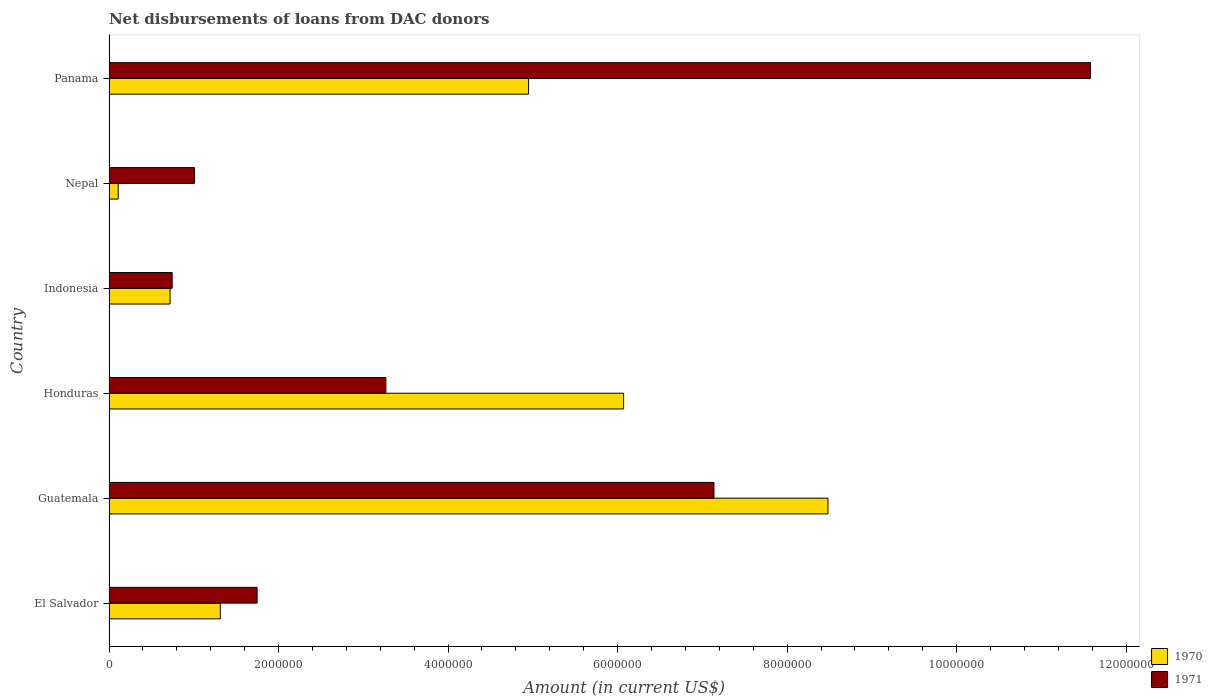Are the number of bars on each tick of the Y-axis equal?
Give a very brief answer. Yes. How many bars are there on the 4th tick from the top?
Make the answer very short. 2. How many bars are there on the 6th tick from the bottom?
Your answer should be very brief. 2. What is the label of the 4th group of bars from the top?
Ensure brevity in your answer.  Honduras. In how many cases, is the number of bars for a given country not equal to the number of legend labels?
Provide a succinct answer. 0. What is the amount of loans disbursed in 1971 in Guatemala?
Your response must be concise. 7.14e+06. Across all countries, what is the maximum amount of loans disbursed in 1970?
Your answer should be very brief. 8.48e+06. Across all countries, what is the minimum amount of loans disbursed in 1970?
Provide a short and direct response. 1.09e+05. In which country was the amount of loans disbursed in 1971 maximum?
Provide a short and direct response. Panama. In which country was the amount of loans disbursed in 1970 minimum?
Offer a very short reply. Nepal. What is the total amount of loans disbursed in 1970 in the graph?
Provide a short and direct response. 2.16e+07. What is the difference between the amount of loans disbursed in 1971 in Guatemala and that in Nepal?
Give a very brief answer. 6.13e+06. What is the difference between the amount of loans disbursed in 1970 in Nepal and the amount of loans disbursed in 1971 in Guatemala?
Make the answer very short. -7.03e+06. What is the average amount of loans disbursed in 1970 per country?
Your answer should be very brief. 3.61e+06. What is the difference between the amount of loans disbursed in 1970 and amount of loans disbursed in 1971 in Indonesia?
Provide a succinct answer. -2.50e+04. In how many countries, is the amount of loans disbursed in 1971 greater than 8000000 US$?
Your answer should be very brief. 1. What is the ratio of the amount of loans disbursed in 1971 in Guatemala to that in Panama?
Make the answer very short. 0.62. Is the amount of loans disbursed in 1971 in Guatemala less than that in Panama?
Give a very brief answer. Yes. What is the difference between the highest and the second highest amount of loans disbursed in 1970?
Give a very brief answer. 2.41e+06. What is the difference between the highest and the lowest amount of loans disbursed in 1971?
Your response must be concise. 1.08e+07. What does the 1st bar from the bottom in Guatemala represents?
Your answer should be compact. 1970. Are all the bars in the graph horizontal?
Provide a short and direct response. Yes. Does the graph contain any zero values?
Your answer should be compact. No. Does the graph contain grids?
Give a very brief answer. No. How many legend labels are there?
Your response must be concise. 2. How are the legend labels stacked?
Ensure brevity in your answer.  Vertical. What is the title of the graph?
Your response must be concise. Net disbursements of loans from DAC donors. Does "1969" appear as one of the legend labels in the graph?
Offer a terse response. No. What is the label or title of the X-axis?
Your answer should be compact. Amount (in current US$). What is the label or title of the Y-axis?
Keep it short and to the point. Country. What is the Amount (in current US$) in 1970 in El Salvador?
Provide a short and direct response. 1.31e+06. What is the Amount (in current US$) in 1971 in El Salvador?
Offer a very short reply. 1.75e+06. What is the Amount (in current US$) in 1970 in Guatemala?
Your answer should be very brief. 8.48e+06. What is the Amount (in current US$) in 1971 in Guatemala?
Offer a terse response. 7.14e+06. What is the Amount (in current US$) of 1970 in Honduras?
Provide a succinct answer. 6.07e+06. What is the Amount (in current US$) of 1971 in Honduras?
Give a very brief answer. 3.27e+06. What is the Amount (in current US$) in 1970 in Indonesia?
Your answer should be very brief. 7.20e+05. What is the Amount (in current US$) of 1971 in Indonesia?
Offer a terse response. 7.45e+05. What is the Amount (in current US$) of 1970 in Nepal?
Your answer should be compact. 1.09e+05. What is the Amount (in current US$) of 1971 in Nepal?
Your answer should be very brief. 1.01e+06. What is the Amount (in current US$) in 1970 in Panama?
Your answer should be compact. 4.95e+06. What is the Amount (in current US$) of 1971 in Panama?
Give a very brief answer. 1.16e+07. Across all countries, what is the maximum Amount (in current US$) of 1970?
Offer a terse response. 8.48e+06. Across all countries, what is the maximum Amount (in current US$) of 1971?
Your response must be concise. 1.16e+07. Across all countries, what is the minimum Amount (in current US$) of 1970?
Your response must be concise. 1.09e+05. Across all countries, what is the minimum Amount (in current US$) of 1971?
Keep it short and to the point. 7.45e+05. What is the total Amount (in current US$) in 1970 in the graph?
Offer a terse response. 2.16e+07. What is the total Amount (in current US$) in 1971 in the graph?
Your answer should be very brief. 2.55e+07. What is the difference between the Amount (in current US$) of 1970 in El Salvador and that in Guatemala?
Ensure brevity in your answer.  -7.17e+06. What is the difference between the Amount (in current US$) in 1971 in El Salvador and that in Guatemala?
Keep it short and to the point. -5.39e+06. What is the difference between the Amount (in current US$) of 1970 in El Salvador and that in Honduras?
Offer a very short reply. -4.76e+06. What is the difference between the Amount (in current US$) of 1971 in El Salvador and that in Honduras?
Provide a succinct answer. -1.52e+06. What is the difference between the Amount (in current US$) of 1970 in El Salvador and that in Indonesia?
Keep it short and to the point. 5.93e+05. What is the difference between the Amount (in current US$) of 1971 in El Salvador and that in Indonesia?
Your answer should be compact. 1.00e+06. What is the difference between the Amount (in current US$) of 1970 in El Salvador and that in Nepal?
Offer a very short reply. 1.20e+06. What is the difference between the Amount (in current US$) of 1971 in El Salvador and that in Nepal?
Provide a short and direct response. 7.39e+05. What is the difference between the Amount (in current US$) in 1970 in El Salvador and that in Panama?
Ensure brevity in your answer.  -3.64e+06. What is the difference between the Amount (in current US$) of 1971 in El Salvador and that in Panama?
Your answer should be compact. -9.83e+06. What is the difference between the Amount (in current US$) of 1970 in Guatemala and that in Honduras?
Offer a very short reply. 2.41e+06. What is the difference between the Amount (in current US$) of 1971 in Guatemala and that in Honduras?
Ensure brevity in your answer.  3.87e+06. What is the difference between the Amount (in current US$) in 1970 in Guatemala and that in Indonesia?
Offer a terse response. 7.76e+06. What is the difference between the Amount (in current US$) in 1971 in Guatemala and that in Indonesia?
Your response must be concise. 6.39e+06. What is the difference between the Amount (in current US$) in 1970 in Guatemala and that in Nepal?
Give a very brief answer. 8.37e+06. What is the difference between the Amount (in current US$) in 1971 in Guatemala and that in Nepal?
Offer a very short reply. 6.13e+06. What is the difference between the Amount (in current US$) of 1970 in Guatemala and that in Panama?
Offer a terse response. 3.53e+06. What is the difference between the Amount (in current US$) of 1971 in Guatemala and that in Panama?
Provide a succinct answer. -4.44e+06. What is the difference between the Amount (in current US$) of 1970 in Honduras and that in Indonesia?
Your answer should be compact. 5.35e+06. What is the difference between the Amount (in current US$) in 1971 in Honduras and that in Indonesia?
Your answer should be very brief. 2.52e+06. What is the difference between the Amount (in current US$) of 1970 in Honduras and that in Nepal?
Your answer should be compact. 5.96e+06. What is the difference between the Amount (in current US$) of 1971 in Honduras and that in Nepal?
Provide a succinct answer. 2.26e+06. What is the difference between the Amount (in current US$) of 1970 in Honduras and that in Panama?
Your answer should be compact. 1.12e+06. What is the difference between the Amount (in current US$) in 1971 in Honduras and that in Panama?
Provide a short and direct response. -8.31e+06. What is the difference between the Amount (in current US$) of 1970 in Indonesia and that in Nepal?
Offer a terse response. 6.11e+05. What is the difference between the Amount (in current US$) of 1971 in Indonesia and that in Nepal?
Make the answer very short. -2.63e+05. What is the difference between the Amount (in current US$) of 1970 in Indonesia and that in Panama?
Your response must be concise. -4.23e+06. What is the difference between the Amount (in current US$) in 1971 in Indonesia and that in Panama?
Give a very brief answer. -1.08e+07. What is the difference between the Amount (in current US$) of 1970 in Nepal and that in Panama?
Make the answer very short. -4.84e+06. What is the difference between the Amount (in current US$) in 1971 in Nepal and that in Panama?
Provide a short and direct response. -1.06e+07. What is the difference between the Amount (in current US$) in 1970 in El Salvador and the Amount (in current US$) in 1971 in Guatemala?
Your response must be concise. -5.82e+06. What is the difference between the Amount (in current US$) in 1970 in El Salvador and the Amount (in current US$) in 1971 in Honduras?
Your response must be concise. -1.95e+06. What is the difference between the Amount (in current US$) of 1970 in El Salvador and the Amount (in current US$) of 1971 in Indonesia?
Provide a succinct answer. 5.68e+05. What is the difference between the Amount (in current US$) of 1970 in El Salvador and the Amount (in current US$) of 1971 in Nepal?
Give a very brief answer. 3.05e+05. What is the difference between the Amount (in current US$) in 1970 in El Salvador and the Amount (in current US$) in 1971 in Panama?
Provide a short and direct response. -1.03e+07. What is the difference between the Amount (in current US$) in 1970 in Guatemala and the Amount (in current US$) in 1971 in Honduras?
Offer a terse response. 5.22e+06. What is the difference between the Amount (in current US$) in 1970 in Guatemala and the Amount (in current US$) in 1971 in Indonesia?
Provide a succinct answer. 7.74e+06. What is the difference between the Amount (in current US$) in 1970 in Guatemala and the Amount (in current US$) in 1971 in Nepal?
Your answer should be very brief. 7.47e+06. What is the difference between the Amount (in current US$) of 1970 in Guatemala and the Amount (in current US$) of 1971 in Panama?
Your answer should be very brief. -3.10e+06. What is the difference between the Amount (in current US$) of 1970 in Honduras and the Amount (in current US$) of 1971 in Indonesia?
Make the answer very short. 5.33e+06. What is the difference between the Amount (in current US$) in 1970 in Honduras and the Amount (in current US$) in 1971 in Nepal?
Offer a terse response. 5.06e+06. What is the difference between the Amount (in current US$) of 1970 in Honduras and the Amount (in current US$) of 1971 in Panama?
Offer a terse response. -5.51e+06. What is the difference between the Amount (in current US$) in 1970 in Indonesia and the Amount (in current US$) in 1971 in Nepal?
Provide a short and direct response. -2.88e+05. What is the difference between the Amount (in current US$) of 1970 in Indonesia and the Amount (in current US$) of 1971 in Panama?
Offer a terse response. -1.09e+07. What is the difference between the Amount (in current US$) of 1970 in Nepal and the Amount (in current US$) of 1971 in Panama?
Ensure brevity in your answer.  -1.15e+07. What is the average Amount (in current US$) of 1970 per country?
Give a very brief answer. 3.61e+06. What is the average Amount (in current US$) in 1971 per country?
Provide a succinct answer. 4.25e+06. What is the difference between the Amount (in current US$) of 1970 and Amount (in current US$) of 1971 in El Salvador?
Give a very brief answer. -4.34e+05. What is the difference between the Amount (in current US$) in 1970 and Amount (in current US$) in 1971 in Guatemala?
Your response must be concise. 1.34e+06. What is the difference between the Amount (in current US$) of 1970 and Amount (in current US$) of 1971 in Honduras?
Offer a very short reply. 2.80e+06. What is the difference between the Amount (in current US$) of 1970 and Amount (in current US$) of 1971 in Indonesia?
Your answer should be very brief. -2.50e+04. What is the difference between the Amount (in current US$) of 1970 and Amount (in current US$) of 1971 in Nepal?
Your answer should be compact. -8.99e+05. What is the difference between the Amount (in current US$) of 1970 and Amount (in current US$) of 1971 in Panama?
Your answer should be very brief. -6.63e+06. What is the ratio of the Amount (in current US$) of 1970 in El Salvador to that in Guatemala?
Your answer should be compact. 0.15. What is the ratio of the Amount (in current US$) of 1971 in El Salvador to that in Guatemala?
Ensure brevity in your answer.  0.24. What is the ratio of the Amount (in current US$) in 1970 in El Salvador to that in Honduras?
Provide a succinct answer. 0.22. What is the ratio of the Amount (in current US$) in 1971 in El Salvador to that in Honduras?
Ensure brevity in your answer.  0.53. What is the ratio of the Amount (in current US$) in 1970 in El Salvador to that in Indonesia?
Keep it short and to the point. 1.82. What is the ratio of the Amount (in current US$) in 1971 in El Salvador to that in Indonesia?
Give a very brief answer. 2.35. What is the ratio of the Amount (in current US$) in 1970 in El Salvador to that in Nepal?
Provide a short and direct response. 12.05. What is the ratio of the Amount (in current US$) of 1971 in El Salvador to that in Nepal?
Provide a succinct answer. 1.73. What is the ratio of the Amount (in current US$) in 1970 in El Salvador to that in Panama?
Offer a very short reply. 0.27. What is the ratio of the Amount (in current US$) of 1971 in El Salvador to that in Panama?
Make the answer very short. 0.15. What is the ratio of the Amount (in current US$) in 1970 in Guatemala to that in Honduras?
Give a very brief answer. 1.4. What is the ratio of the Amount (in current US$) of 1971 in Guatemala to that in Honduras?
Provide a succinct answer. 2.19. What is the ratio of the Amount (in current US$) in 1970 in Guatemala to that in Indonesia?
Provide a short and direct response. 11.78. What is the ratio of the Amount (in current US$) of 1971 in Guatemala to that in Indonesia?
Your response must be concise. 9.58. What is the ratio of the Amount (in current US$) of 1970 in Guatemala to that in Nepal?
Provide a short and direct response. 77.82. What is the ratio of the Amount (in current US$) in 1971 in Guatemala to that in Nepal?
Your answer should be very brief. 7.08. What is the ratio of the Amount (in current US$) in 1970 in Guatemala to that in Panama?
Your answer should be compact. 1.71. What is the ratio of the Amount (in current US$) of 1971 in Guatemala to that in Panama?
Make the answer very short. 0.62. What is the ratio of the Amount (in current US$) in 1970 in Honduras to that in Indonesia?
Your answer should be compact. 8.43. What is the ratio of the Amount (in current US$) in 1971 in Honduras to that in Indonesia?
Make the answer very short. 4.38. What is the ratio of the Amount (in current US$) in 1970 in Honduras to that in Nepal?
Your answer should be compact. 55.7. What is the ratio of the Amount (in current US$) in 1971 in Honduras to that in Nepal?
Offer a terse response. 3.24. What is the ratio of the Amount (in current US$) of 1970 in Honduras to that in Panama?
Your answer should be very brief. 1.23. What is the ratio of the Amount (in current US$) in 1971 in Honduras to that in Panama?
Provide a short and direct response. 0.28. What is the ratio of the Amount (in current US$) of 1970 in Indonesia to that in Nepal?
Provide a succinct answer. 6.61. What is the ratio of the Amount (in current US$) of 1971 in Indonesia to that in Nepal?
Offer a very short reply. 0.74. What is the ratio of the Amount (in current US$) in 1970 in Indonesia to that in Panama?
Ensure brevity in your answer.  0.15. What is the ratio of the Amount (in current US$) in 1971 in Indonesia to that in Panama?
Provide a succinct answer. 0.06. What is the ratio of the Amount (in current US$) in 1970 in Nepal to that in Panama?
Give a very brief answer. 0.02. What is the ratio of the Amount (in current US$) in 1971 in Nepal to that in Panama?
Your response must be concise. 0.09. What is the difference between the highest and the second highest Amount (in current US$) in 1970?
Make the answer very short. 2.41e+06. What is the difference between the highest and the second highest Amount (in current US$) of 1971?
Ensure brevity in your answer.  4.44e+06. What is the difference between the highest and the lowest Amount (in current US$) in 1970?
Ensure brevity in your answer.  8.37e+06. What is the difference between the highest and the lowest Amount (in current US$) in 1971?
Make the answer very short. 1.08e+07. 